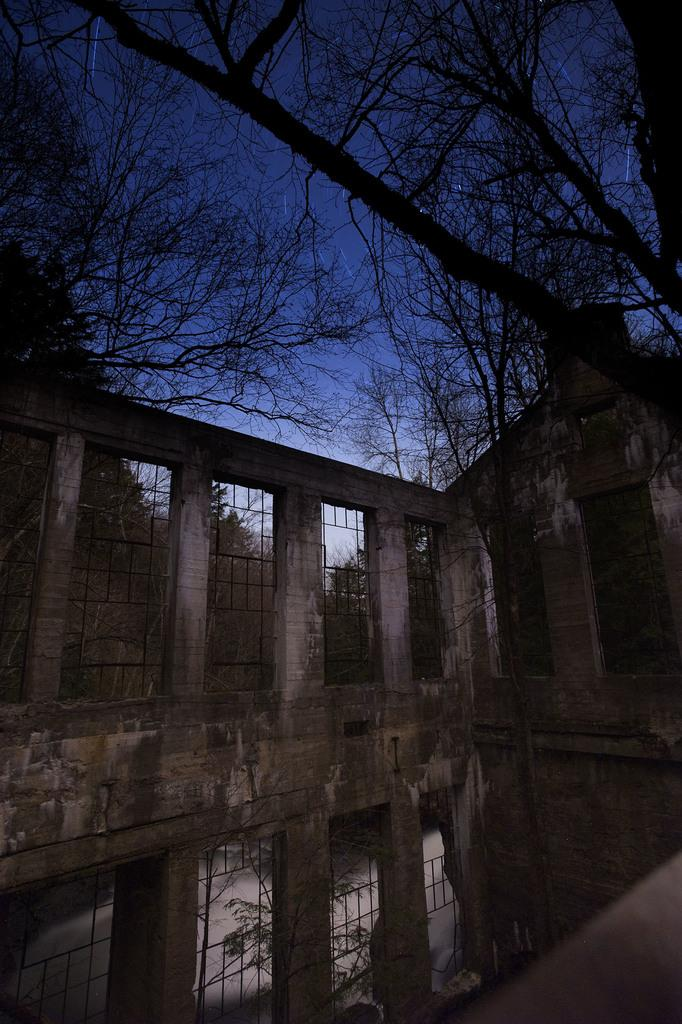What type of location is depicted in the image? The image shows an inside view of a building. What architectural feature can be seen in the image? There are iron grills visible in the image. What can be seen in the background of the image? There are trees and the clear sky visible in the background of the image. How many plates are being used by the slaves in the image? There are no plates or slaves present in the image. What type of sky is depicted in the image? The sky is clear and visible in the background of the image. 